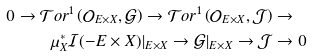Convert formula to latex. <formula><loc_0><loc_0><loc_500><loc_500>0 \to \mathcal { T } o r ^ { 1 } \left ( \mathcal { O } _ { E \times X } , \mathcal { G } \right ) \to \mathcal { T } o r ^ { 1 } \left ( \mathcal { O } _ { E \times X } , \mathcal { J } \right ) & \to \\ \mu _ { X } ^ { * } \mathcal { I } ( - E \times X ) | _ { E \times X } \to \mathcal { G } | _ { E \times X } \to \mathcal { J } & \to 0</formula> 